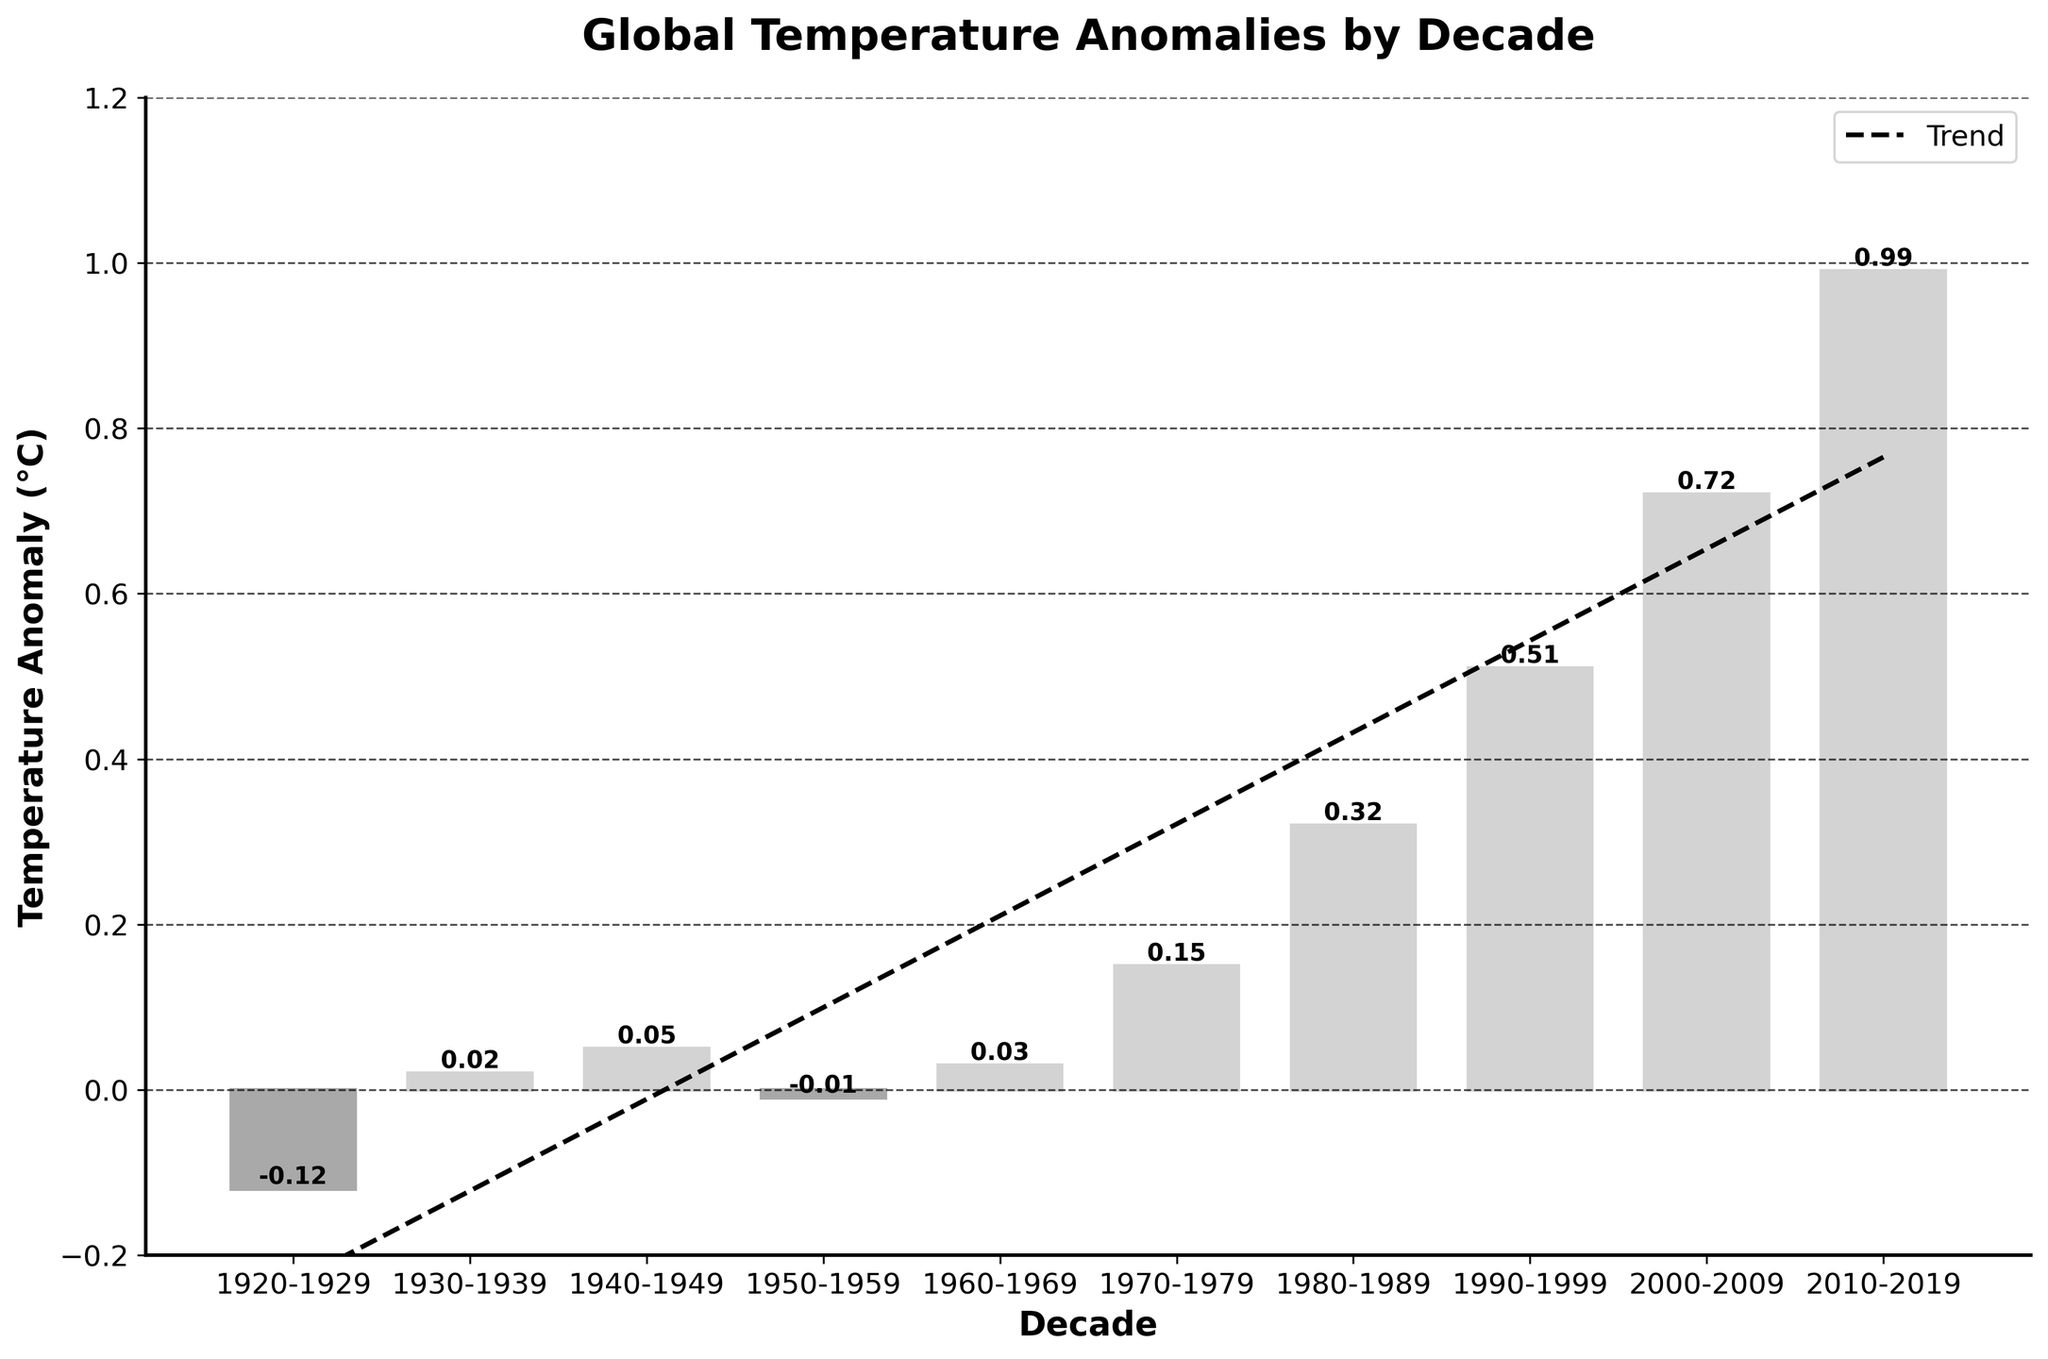What is the temperature anomaly for the decade 1920-1929? The bar for the decade 1920-1929 shows a height indicating a temperature anomaly of -0.12°C.
Answer: -0.12°C Which decade has the highest temperature anomaly? By observing the height of the bars, the decade 2010-2019 has the highest bar, indicating the highest temperature anomaly of 0.99°C.
Answer: 2010-2019 How many decades have negative temperature anomalies? The bars indicating negative temperature anomalies are those for the decades 1920-1929 and 1950-1959.
Answer: 2 What is the difference in temperature anomaly between the decades 1990-1999 and 2000-2009? Subtract the temperature anomaly of 1990-1999 (0.51°C) from that of 2000-2009 (0.72°C). 0.72 - 0.51 = 0.21°C
Answer: 0.21°C Which decades have a temperature anomaly greater than or equal to 0.50°C? The bars for the decades 1990-1999 (0.51°C), 2000-2009 (0.72°C), and 2010-2019 (0.99°C) all show temperature anomalies greater than or equal to 0.50°C.
Answer: 1990-1999, 2000-2009, 2010-2019 Is there a visible trend in the temperature anomalies over the decades? The trend line, represented by a dashed line, shows an upward slope, indicating an increasing trend in temperature anomalies over the decades.
Answer: Yes What is the average temperature anomaly from 1980-2019? Sum the anomalies from 1980-1989 (0.32°C), 1990-1999 (0.51°C), 2000-2009 (0.72°C), and 2010-2019 (0.99°C). Divide this sum by 4 to find the average:
(0.32 + 0.51 + 0.72 + 0.99) / 4 = 2.54 / 4 = 0.635°C
Answer: 0.64°C Which decade showed the first positive temperature anomaly during the 20th century? The bar for the decade 1930-1939 has the first positive anomaly at 0.02°C in the 20th century.
Answer: 1930-1939 